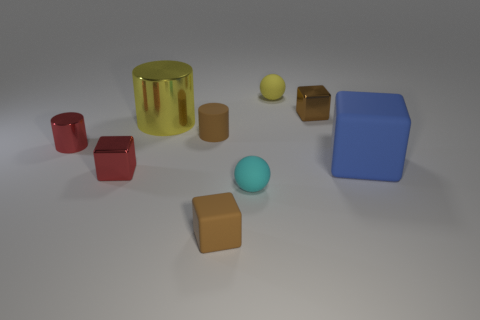Subtract all metal cylinders. How many cylinders are left? 1 Subtract all brown blocks. How many blocks are left? 2 Subtract 2 cylinders. How many cylinders are left? 1 Subtract all red spheres. How many brown cubes are left? 2 Subtract all blue cylinders. Subtract all green cubes. How many cylinders are left? 3 Subtract 0 green blocks. How many objects are left? 9 Subtract all cylinders. How many objects are left? 6 Subtract all brown things. Subtract all yellow things. How many objects are left? 4 Add 7 brown cubes. How many brown cubes are left? 9 Add 7 big cyan metallic cylinders. How many big cyan metallic cylinders exist? 7 